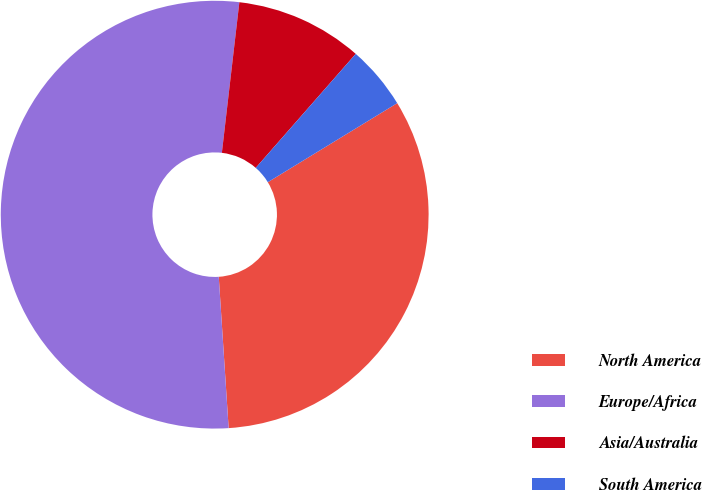Convert chart to OTSL. <chart><loc_0><loc_0><loc_500><loc_500><pie_chart><fcel>North America<fcel>Europe/Africa<fcel>Asia/Australia<fcel>South America<nl><fcel>32.69%<fcel>52.88%<fcel>9.62%<fcel>4.81%<nl></chart> 